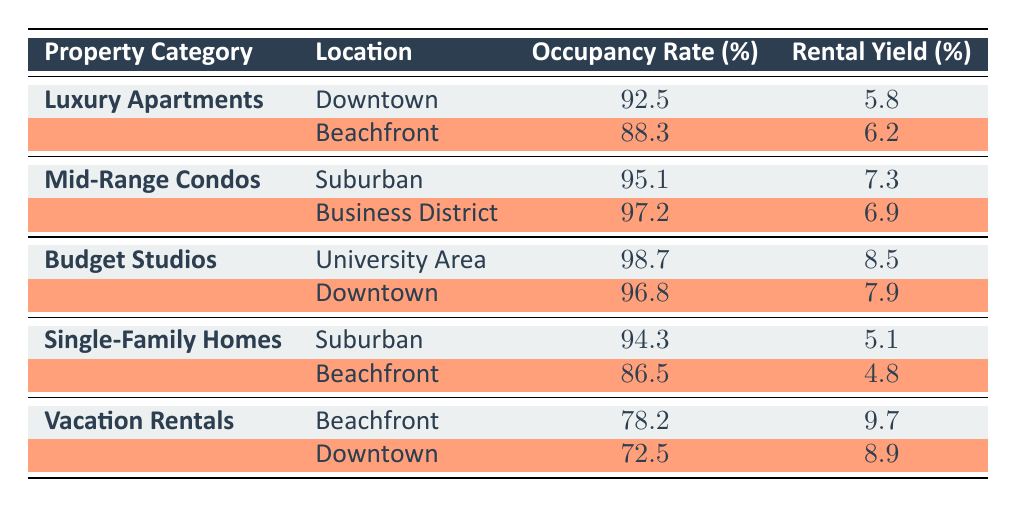What is the highest occupancy rate among the property categories? The highest occupancy rate is found by comparing the occupancy rates listed for each category. The rates are 92.5% for Luxury Apartments (Downtown), 88.3% (Beachfront), 95.1% (Mid-Range Condos, Suburban), 97.2% (Mid-Range Condos, Business District), 98.7% (Budget Studios, University Area), 96.8% (Budget Studios, Downtown), 94.3% (Single-Family Homes, Suburban), 86.5% (Single-Family Homes, Beachfront), 78.2% (Vacation Rentals, Beachfront), and 72.5% (Vacation Rentals, Downtown). The highest is 98.7%, which is for Budget Studios in the University Area.
Answer: 98.7 Which property category has the lowest rental yield? To find the lowest rental yield, the yields for each category are compared: 5.8% (Luxury Apartments, Downtown), 6.2% (Luxury Apartments, Beachfront), 7.3% (Mid-Range Condos, Suburban), 6.9% (Mid-Range Condos, Business District), 8.5% (Budget Studios, University Area), 7.9% (Budget Studios, Downtown), 5.1% (Single-Family Homes, Suburban), 4.8% (Single-Family Homes, Beachfront), 9.7% (Vacation Rentals, Beachfront), and 8.9% (Vacation Rentals, Downtown). The category with the lowest yield is Single-Family Homes at the Beachfront with 4.8%.
Answer: 4.8 Is the occupancy rate for Vacation Rentals in Downtown higher than in Beachfront? The occupancy rate for Vacation Rentals in Downtown is 72.5%, while in Beachfront it is 78.2%. Since 72.5% is less than 78.2%, this is false.
Answer: No What is the average rental yield for Mid-Range Condos? To find the average rental yield for Mid-Range Condos, we take the rental yields from both locations: 7.3% (Suburban) and 6.9% (Business District). The sum is 7.3 + 6.9 = 14.2 and then divide by 2, which gives us 14.2 / 2 = 7.1%.
Answer: 7.1 Which property category has a higher occupancy rate, Budget Studios or Single-Family Homes? Comparing the occupancy rates, Budget Studios have 98.7% (University Area) and 96.8% (Downtown), while Single-Family Homes have 94.3% (Suburban) and 86.5% (Beachfront). Both occupancy rates for Budget Studios exceed those for Single-Family Homes, confirming Budget Studios have a higher occupancy rate.
Answer: Budget Studios How many locations have an occupancy rate above 90%? By examining the occupancy rates, we identify the ones above 90%: 92.5% (Luxury Apartments, Downtown), 95.1% (Mid-Range Condos, Suburban), 97.2% (Mid-Range Condos, Business District), 98.7% (Budget Studios, University Area), 96.8% (Budget Studios, Downtown), and 94.3% (Single-Family Homes, Suburban). That gives us a total of 6 locations.
Answer: 6 Are there any property categories with an occupancy rate over 95%? Reviewing the rates, we find that Budget Studios (98.7%), Mid-Range Condos (95.1% and 97.2%), and Luxury Apartments (92.5%) meet the criterion. Since Budget Studios and Mid-Range Condos both exceed 95%, the statement is true.
Answer: Yes What is the difference in rental yield between Vacation Rentals at Beachfront and Budget Studios in University Area? The rental yield for Vacation Rentals at Beachfront is 9.7%, and for Budget Studios in University Area, it is 8.5%. To find the difference, we subtract 8.5 from 9.7, giving us a difference of 1.2%.
Answer: 1.2 